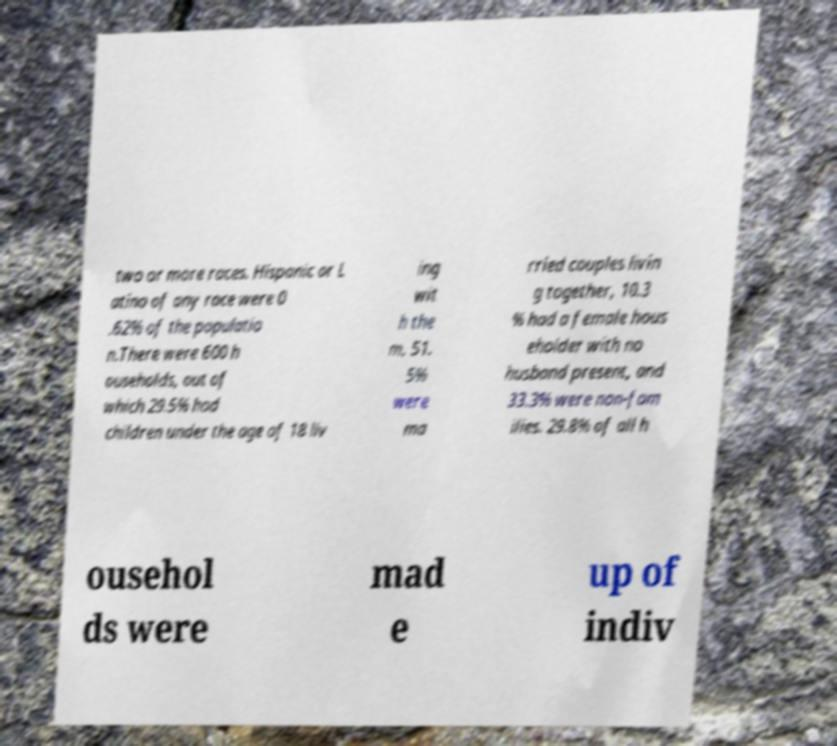There's text embedded in this image that I need extracted. Can you transcribe it verbatim? two or more races. Hispanic or L atino of any race were 0 .62% of the populatio n.There were 600 h ouseholds, out of which 29.5% had children under the age of 18 liv ing wit h the m, 51. 5% were ma rried couples livin g together, 10.3 % had a female hous eholder with no husband present, and 33.3% were non-fam ilies. 29.8% of all h ousehol ds were mad e up of indiv 